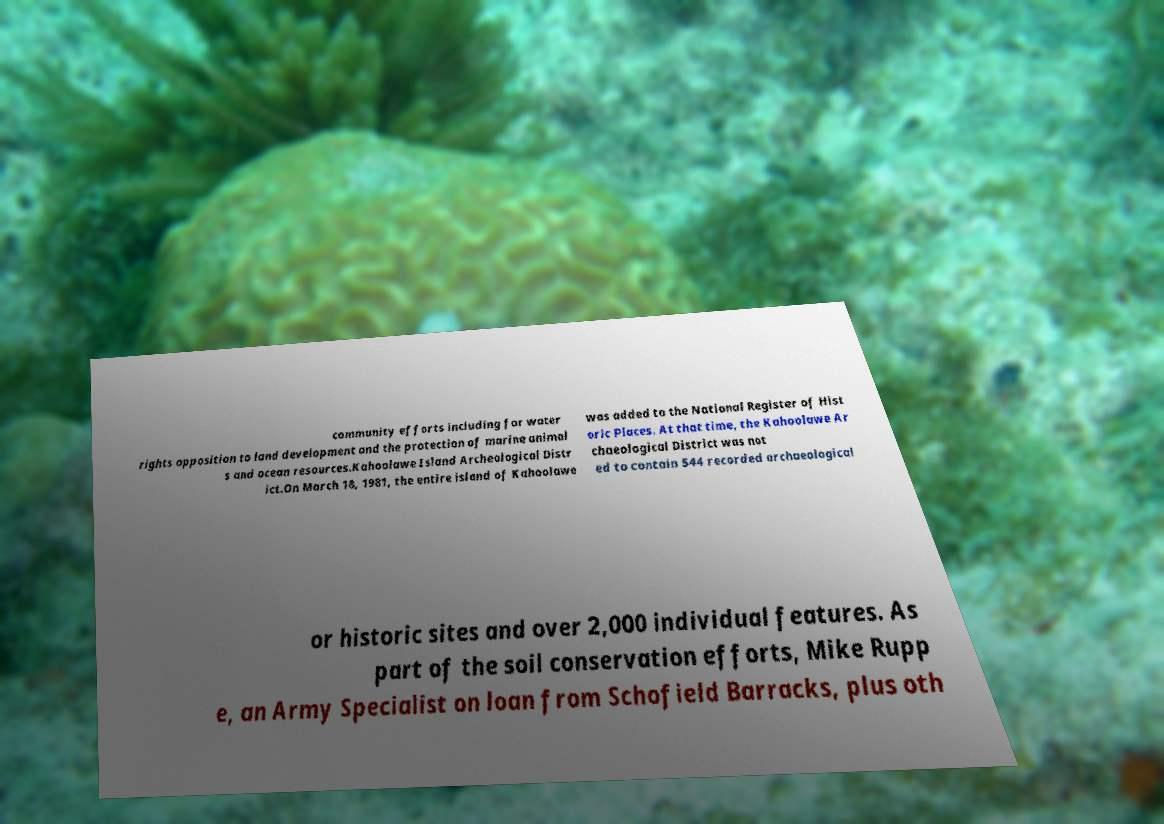Please read and relay the text visible in this image. What does it say? community efforts including for water rights opposition to land development and the protection of marine animal s and ocean resources.Kahoolawe Island Archeological Distr ict.On March 18, 1981, the entire island of Kahoolawe was added to the National Register of Hist oric Places. At that time, the Kahoolawe Ar chaeological District was not ed to contain 544 recorded archaeological or historic sites and over 2,000 individual features. As part of the soil conservation efforts, Mike Rupp e, an Army Specialist on loan from Schofield Barracks, plus oth 